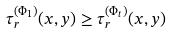<formula> <loc_0><loc_0><loc_500><loc_500>\tau _ { r } ^ { ( \Phi _ { 1 } ) } ( x , y ) \geq \tau _ { r } ^ { ( \Phi _ { t } ) } ( x , y )</formula> 